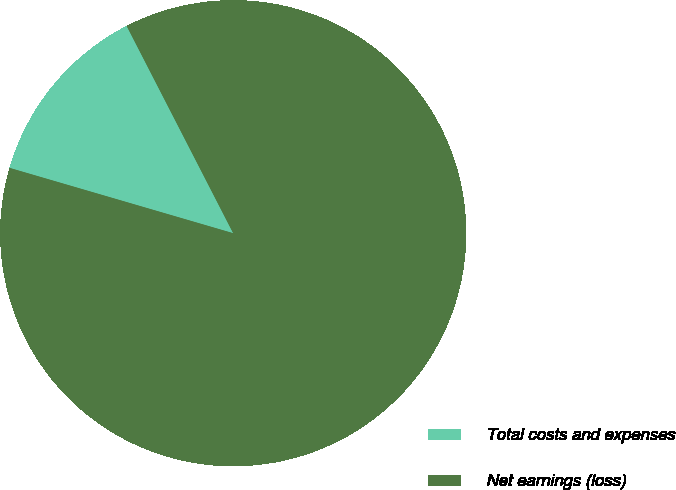Convert chart. <chart><loc_0><loc_0><loc_500><loc_500><pie_chart><fcel>Total costs and expenses<fcel>Net earnings (loss)<nl><fcel>12.92%<fcel>87.08%<nl></chart> 